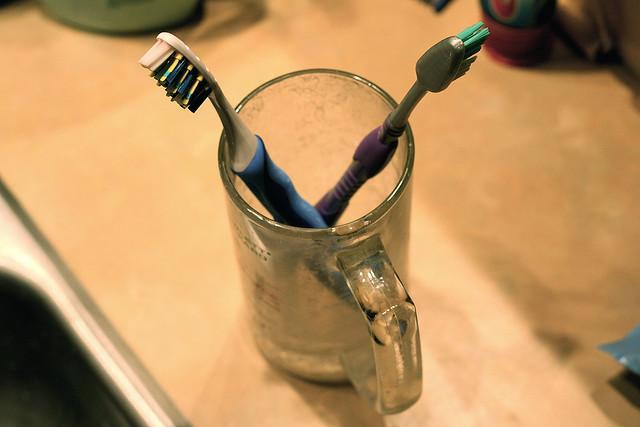How many people use this bathroom?

Choices:
A) five
B) four
C) six
D) two two 